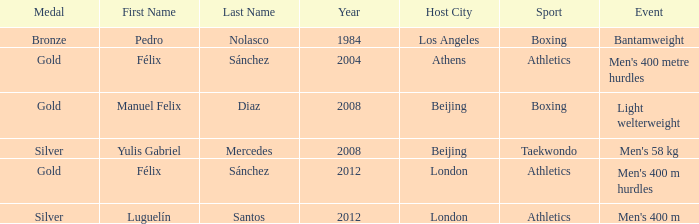In the 2008 beijing games, which medal was won in the taekwondo category? Silver. 